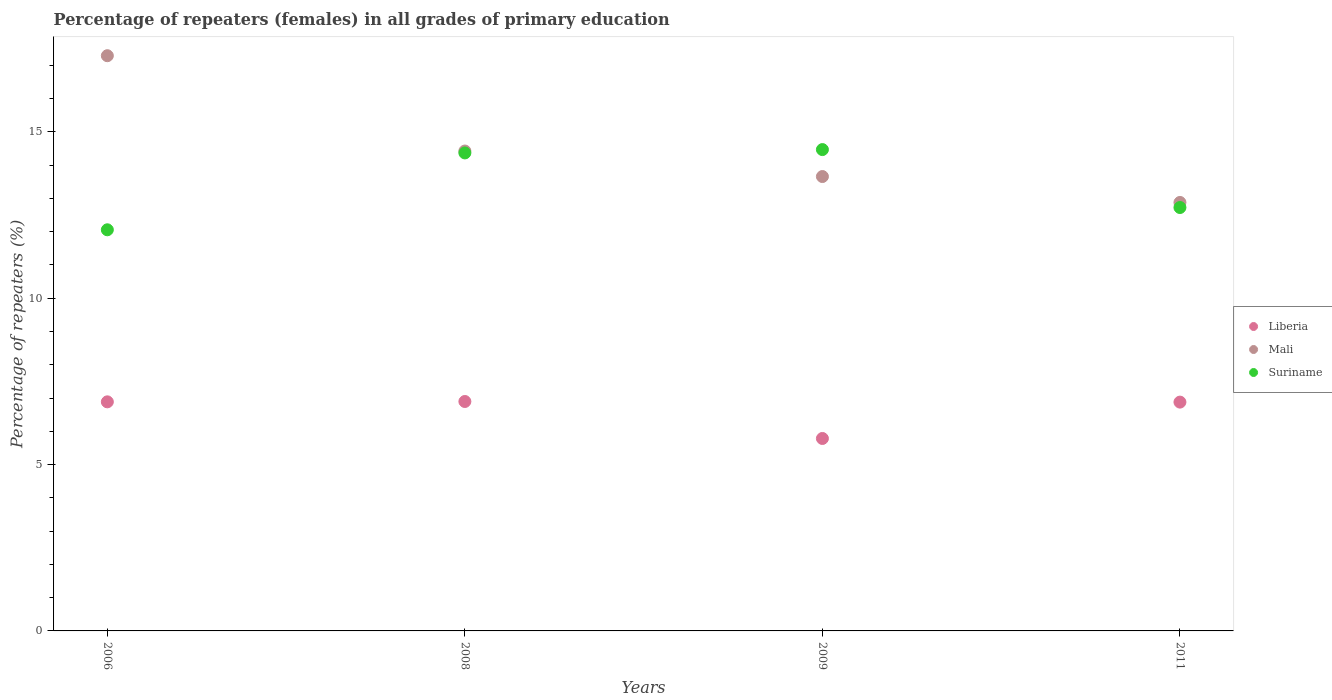Is the number of dotlines equal to the number of legend labels?
Offer a very short reply. Yes. What is the percentage of repeaters (females) in Liberia in 2006?
Provide a short and direct response. 6.88. Across all years, what is the maximum percentage of repeaters (females) in Liberia?
Your response must be concise. 6.9. Across all years, what is the minimum percentage of repeaters (females) in Liberia?
Your answer should be very brief. 5.78. In which year was the percentage of repeaters (females) in Liberia minimum?
Keep it short and to the point. 2009. What is the total percentage of repeaters (females) in Mali in the graph?
Offer a very short reply. 58.24. What is the difference between the percentage of repeaters (females) in Mali in 2008 and that in 2009?
Keep it short and to the point. 0.77. What is the difference between the percentage of repeaters (females) in Suriname in 2006 and the percentage of repeaters (females) in Liberia in 2009?
Provide a short and direct response. 6.27. What is the average percentage of repeaters (females) in Liberia per year?
Offer a terse response. 6.61. In the year 2009, what is the difference between the percentage of repeaters (females) in Suriname and percentage of repeaters (females) in Mali?
Keep it short and to the point. 0.81. What is the ratio of the percentage of repeaters (females) in Liberia in 2008 to that in 2011?
Offer a terse response. 1. What is the difference between the highest and the second highest percentage of repeaters (females) in Mali?
Ensure brevity in your answer.  2.86. What is the difference between the highest and the lowest percentage of repeaters (females) in Suriname?
Make the answer very short. 2.41. In how many years, is the percentage of repeaters (females) in Mali greater than the average percentage of repeaters (females) in Mali taken over all years?
Give a very brief answer. 1. Does the percentage of repeaters (females) in Liberia monotonically increase over the years?
Provide a short and direct response. No. Is the percentage of repeaters (females) in Mali strictly greater than the percentage of repeaters (females) in Suriname over the years?
Your response must be concise. No. How many dotlines are there?
Your answer should be compact. 3. Are the values on the major ticks of Y-axis written in scientific E-notation?
Make the answer very short. No. Does the graph contain grids?
Provide a succinct answer. No. What is the title of the graph?
Keep it short and to the point. Percentage of repeaters (females) in all grades of primary education. What is the label or title of the X-axis?
Keep it short and to the point. Years. What is the label or title of the Y-axis?
Your answer should be compact. Percentage of repeaters (%). What is the Percentage of repeaters (%) in Liberia in 2006?
Provide a succinct answer. 6.88. What is the Percentage of repeaters (%) of Mali in 2006?
Offer a very short reply. 17.29. What is the Percentage of repeaters (%) in Suriname in 2006?
Make the answer very short. 12.06. What is the Percentage of repeaters (%) in Liberia in 2008?
Offer a terse response. 6.9. What is the Percentage of repeaters (%) of Mali in 2008?
Offer a terse response. 14.42. What is the Percentage of repeaters (%) of Suriname in 2008?
Your response must be concise. 14.37. What is the Percentage of repeaters (%) in Liberia in 2009?
Your answer should be very brief. 5.78. What is the Percentage of repeaters (%) in Mali in 2009?
Provide a succinct answer. 13.66. What is the Percentage of repeaters (%) in Suriname in 2009?
Your answer should be very brief. 14.47. What is the Percentage of repeaters (%) in Liberia in 2011?
Keep it short and to the point. 6.88. What is the Percentage of repeaters (%) of Mali in 2011?
Offer a terse response. 12.88. What is the Percentage of repeaters (%) of Suriname in 2011?
Ensure brevity in your answer.  12.73. Across all years, what is the maximum Percentage of repeaters (%) of Liberia?
Your answer should be compact. 6.9. Across all years, what is the maximum Percentage of repeaters (%) of Mali?
Give a very brief answer. 17.29. Across all years, what is the maximum Percentage of repeaters (%) in Suriname?
Offer a very short reply. 14.47. Across all years, what is the minimum Percentage of repeaters (%) of Liberia?
Make the answer very short. 5.78. Across all years, what is the minimum Percentage of repeaters (%) in Mali?
Provide a succinct answer. 12.88. Across all years, what is the minimum Percentage of repeaters (%) in Suriname?
Keep it short and to the point. 12.06. What is the total Percentage of repeaters (%) in Liberia in the graph?
Your response must be concise. 26.44. What is the total Percentage of repeaters (%) of Mali in the graph?
Ensure brevity in your answer.  58.24. What is the total Percentage of repeaters (%) of Suriname in the graph?
Give a very brief answer. 53.61. What is the difference between the Percentage of repeaters (%) of Liberia in 2006 and that in 2008?
Provide a succinct answer. -0.01. What is the difference between the Percentage of repeaters (%) in Mali in 2006 and that in 2008?
Provide a short and direct response. 2.86. What is the difference between the Percentage of repeaters (%) of Suriname in 2006 and that in 2008?
Provide a succinct answer. -2.31. What is the difference between the Percentage of repeaters (%) in Liberia in 2006 and that in 2009?
Give a very brief answer. 1.1. What is the difference between the Percentage of repeaters (%) in Mali in 2006 and that in 2009?
Provide a succinct answer. 3.63. What is the difference between the Percentage of repeaters (%) of Suriname in 2006 and that in 2009?
Your answer should be compact. -2.41. What is the difference between the Percentage of repeaters (%) in Liberia in 2006 and that in 2011?
Keep it short and to the point. 0.01. What is the difference between the Percentage of repeaters (%) in Mali in 2006 and that in 2011?
Your answer should be very brief. 4.41. What is the difference between the Percentage of repeaters (%) of Suriname in 2006 and that in 2011?
Provide a short and direct response. -0.67. What is the difference between the Percentage of repeaters (%) in Liberia in 2008 and that in 2009?
Your response must be concise. 1.11. What is the difference between the Percentage of repeaters (%) in Mali in 2008 and that in 2009?
Ensure brevity in your answer.  0.77. What is the difference between the Percentage of repeaters (%) in Suriname in 2008 and that in 2009?
Make the answer very short. -0.1. What is the difference between the Percentage of repeaters (%) of Liberia in 2008 and that in 2011?
Make the answer very short. 0.02. What is the difference between the Percentage of repeaters (%) of Mali in 2008 and that in 2011?
Provide a short and direct response. 1.55. What is the difference between the Percentage of repeaters (%) of Suriname in 2008 and that in 2011?
Ensure brevity in your answer.  1.64. What is the difference between the Percentage of repeaters (%) in Liberia in 2009 and that in 2011?
Offer a terse response. -1.09. What is the difference between the Percentage of repeaters (%) in Mali in 2009 and that in 2011?
Provide a short and direct response. 0.78. What is the difference between the Percentage of repeaters (%) of Suriname in 2009 and that in 2011?
Ensure brevity in your answer.  1.74. What is the difference between the Percentage of repeaters (%) of Liberia in 2006 and the Percentage of repeaters (%) of Mali in 2008?
Provide a short and direct response. -7.54. What is the difference between the Percentage of repeaters (%) of Liberia in 2006 and the Percentage of repeaters (%) of Suriname in 2008?
Keep it short and to the point. -7.48. What is the difference between the Percentage of repeaters (%) in Mali in 2006 and the Percentage of repeaters (%) in Suriname in 2008?
Offer a very short reply. 2.92. What is the difference between the Percentage of repeaters (%) in Liberia in 2006 and the Percentage of repeaters (%) in Mali in 2009?
Your answer should be compact. -6.77. What is the difference between the Percentage of repeaters (%) of Liberia in 2006 and the Percentage of repeaters (%) of Suriname in 2009?
Your response must be concise. -7.58. What is the difference between the Percentage of repeaters (%) of Mali in 2006 and the Percentage of repeaters (%) of Suriname in 2009?
Provide a succinct answer. 2.82. What is the difference between the Percentage of repeaters (%) of Liberia in 2006 and the Percentage of repeaters (%) of Mali in 2011?
Give a very brief answer. -5.99. What is the difference between the Percentage of repeaters (%) in Liberia in 2006 and the Percentage of repeaters (%) in Suriname in 2011?
Your response must be concise. -5.84. What is the difference between the Percentage of repeaters (%) in Mali in 2006 and the Percentage of repeaters (%) in Suriname in 2011?
Your answer should be very brief. 4.56. What is the difference between the Percentage of repeaters (%) in Liberia in 2008 and the Percentage of repeaters (%) in Mali in 2009?
Offer a very short reply. -6.76. What is the difference between the Percentage of repeaters (%) in Liberia in 2008 and the Percentage of repeaters (%) in Suriname in 2009?
Your answer should be very brief. -7.57. What is the difference between the Percentage of repeaters (%) in Mali in 2008 and the Percentage of repeaters (%) in Suriname in 2009?
Offer a terse response. -0.04. What is the difference between the Percentage of repeaters (%) in Liberia in 2008 and the Percentage of repeaters (%) in Mali in 2011?
Your response must be concise. -5.98. What is the difference between the Percentage of repeaters (%) of Liberia in 2008 and the Percentage of repeaters (%) of Suriname in 2011?
Provide a succinct answer. -5.83. What is the difference between the Percentage of repeaters (%) of Mali in 2008 and the Percentage of repeaters (%) of Suriname in 2011?
Your answer should be compact. 1.7. What is the difference between the Percentage of repeaters (%) of Liberia in 2009 and the Percentage of repeaters (%) of Mali in 2011?
Keep it short and to the point. -7.09. What is the difference between the Percentage of repeaters (%) of Liberia in 2009 and the Percentage of repeaters (%) of Suriname in 2011?
Make the answer very short. -6.94. What is the difference between the Percentage of repeaters (%) of Mali in 2009 and the Percentage of repeaters (%) of Suriname in 2011?
Provide a succinct answer. 0.93. What is the average Percentage of repeaters (%) in Liberia per year?
Offer a very short reply. 6.61. What is the average Percentage of repeaters (%) of Mali per year?
Provide a succinct answer. 14.56. What is the average Percentage of repeaters (%) in Suriname per year?
Keep it short and to the point. 13.4. In the year 2006, what is the difference between the Percentage of repeaters (%) in Liberia and Percentage of repeaters (%) in Mali?
Offer a very short reply. -10.4. In the year 2006, what is the difference between the Percentage of repeaters (%) of Liberia and Percentage of repeaters (%) of Suriname?
Your response must be concise. -5.17. In the year 2006, what is the difference between the Percentage of repeaters (%) of Mali and Percentage of repeaters (%) of Suriname?
Your answer should be compact. 5.23. In the year 2008, what is the difference between the Percentage of repeaters (%) in Liberia and Percentage of repeaters (%) in Mali?
Your response must be concise. -7.53. In the year 2008, what is the difference between the Percentage of repeaters (%) of Liberia and Percentage of repeaters (%) of Suriname?
Your answer should be very brief. -7.47. In the year 2008, what is the difference between the Percentage of repeaters (%) of Mali and Percentage of repeaters (%) of Suriname?
Your answer should be very brief. 0.06. In the year 2009, what is the difference between the Percentage of repeaters (%) in Liberia and Percentage of repeaters (%) in Mali?
Ensure brevity in your answer.  -7.87. In the year 2009, what is the difference between the Percentage of repeaters (%) in Liberia and Percentage of repeaters (%) in Suriname?
Offer a terse response. -8.68. In the year 2009, what is the difference between the Percentage of repeaters (%) of Mali and Percentage of repeaters (%) of Suriname?
Offer a very short reply. -0.81. In the year 2011, what is the difference between the Percentage of repeaters (%) of Liberia and Percentage of repeaters (%) of Mali?
Your answer should be very brief. -6. In the year 2011, what is the difference between the Percentage of repeaters (%) in Liberia and Percentage of repeaters (%) in Suriname?
Your answer should be compact. -5.85. In the year 2011, what is the difference between the Percentage of repeaters (%) of Mali and Percentage of repeaters (%) of Suriname?
Give a very brief answer. 0.15. What is the ratio of the Percentage of repeaters (%) in Mali in 2006 to that in 2008?
Make the answer very short. 1.2. What is the ratio of the Percentage of repeaters (%) in Suriname in 2006 to that in 2008?
Your response must be concise. 0.84. What is the ratio of the Percentage of repeaters (%) in Liberia in 2006 to that in 2009?
Your response must be concise. 1.19. What is the ratio of the Percentage of repeaters (%) of Mali in 2006 to that in 2009?
Your answer should be very brief. 1.27. What is the ratio of the Percentage of repeaters (%) of Suriname in 2006 to that in 2009?
Your answer should be compact. 0.83. What is the ratio of the Percentage of repeaters (%) in Mali in 2006 to that in 2011?
Your answer should be very brief. 1.34. What is the ratio of the Percentage of repeaters (%) of Suriname in 2006 to that in 2011?
Make the answer very short. 0.95. What is the ratio of the Percentage of repeaters (%) in Liberia in 2008 to that in 2009?
Your answer should be compact. 1.19. What is the ratio of the Percentage of repeaters (%) in Mali in 2008 to that in 2009?
Ensure brevity in your answer.  1.06. What is the ratio of the Percentage of repeaters (%) in Suriname in 2008 to that in 2009?
Give a very brief answer. 0.99. What is the ratio of the Percentage of repeaters (%) of Liberia in 2008 to that in 2011?
Provide a succinct answer. 1. What is the ratio of the Percentage of repeaters (%) in Mali in 2008 to that in 2011?
Keep it short and to the point. 1.12. What is the ratio of the Percentage of repeaters (%) of Suriname in 2008 to that in 2011?
Provide a succinct answer. 1.13. What is the ratio of the Percentage of repeaters (%) in Liberia in 2009 to that in 2011?
Your response must be concise. 0.84. What is the ratio of the Percentage of repeaters (%) of Mali in 2009 to that in 2011?
Offer a very short reply. 1.06. What is the ratio of the Percentage of repeaters (%) of Suriname in 2009 to that in 2011?
Provide a succinct answer. 1.14. What is the difference between the highest and the second highest Percentage of repeaters (%) of Liberia?
Your answer should be very brief. 0.01. What is the difference between the highest and the second highest Percentage of repeaters (%) of Mali?
Keep it short and to the point. 2.86. What is the difference between the highest and the second highest Percentage of repeaters (%) in Suriname?
Give a very brief answer. 0.1. What is the difference between the highest and the lowest Percentage of repeaters (%) of Liberia?
Your answer should be compact. 1.11. What is the difference between the highest and the lowest Percentage of repeaters (%) in Mali?
Your response must be concise. 4.41. What is the difference between the highest and the lowest Percentage of repeaters (%) of Suriname?
Provide a short and direct response. 2.41. 